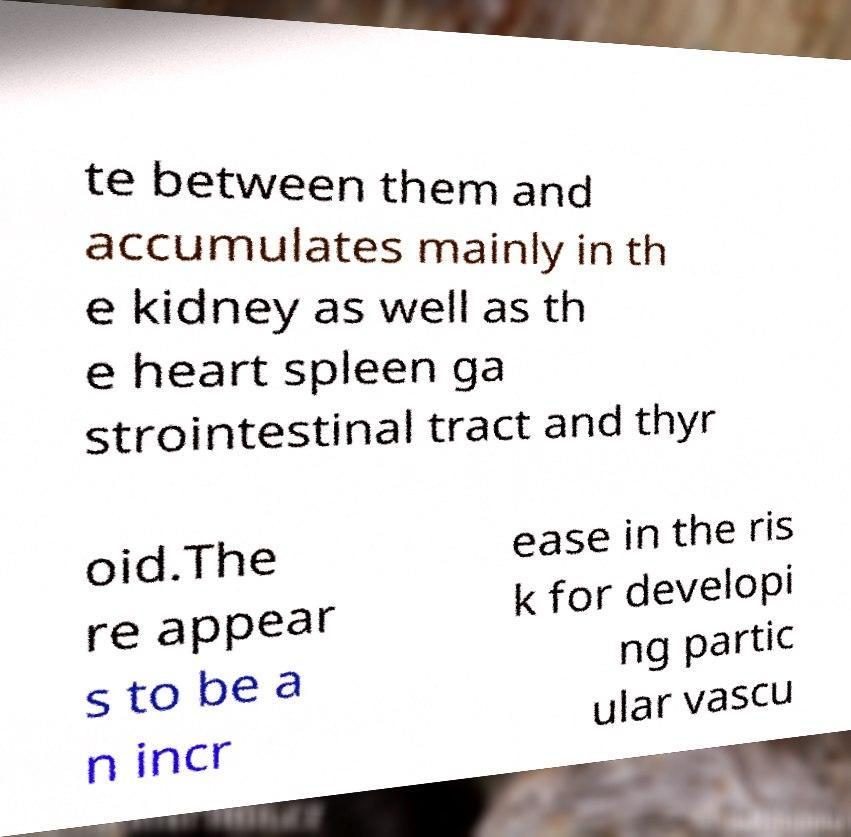Could you assist in decoding the text presented in this image and type it out clearly? te between them and accumulates mainly in th e kidney as well as th e heart spleen ga strointestinal tract and thyr oid.The re appear s to be a n incr ease in the ris k for developi ng partic ular vascu 